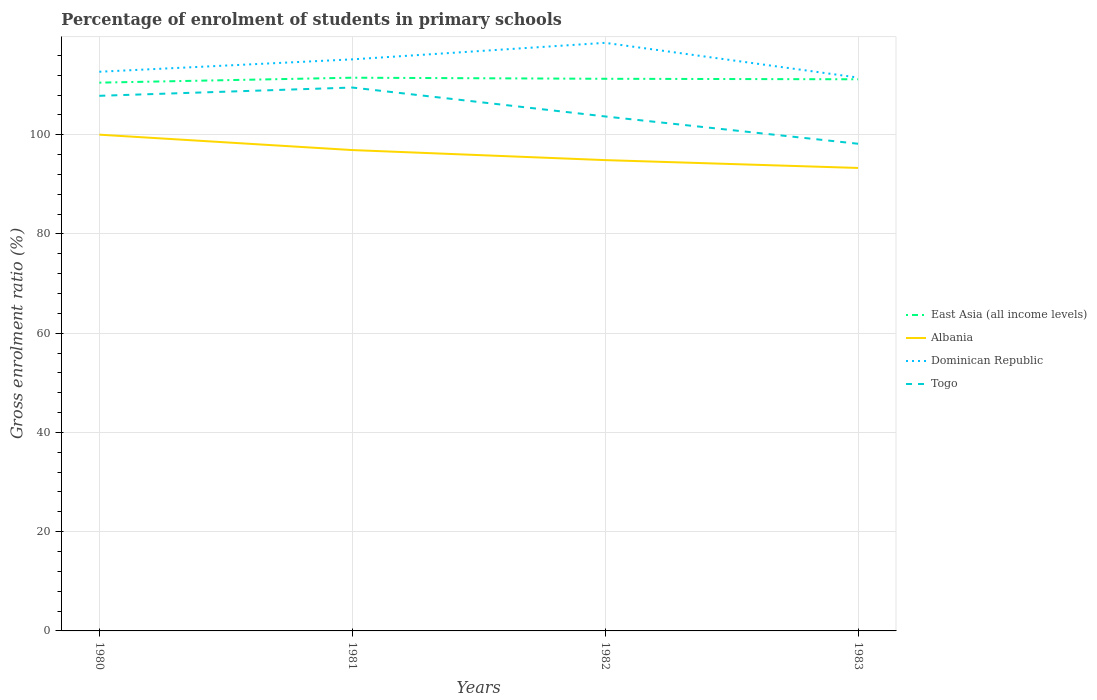Is the number of lines equal to the number of legend labels?
Your answer should be very brief. Yes. Across all years, what is the maximum percentage of students enrolled in primary schools in Dominican Republic?
Give a very brief answer. 111.51. What is the total percentage of students enrolled in primary schools in Dominican Republic in the graph?
Your answer should be very brief. 7. What is the difference between the highest and the second highest percentage of students enrolled in primary schools in Albania?
Offer a terse response. 6.71. What is the difference between the highest and the lowest percentage of students enrolled in primary schools in East Asia (all income levels)?
Offer a terse response. 3. How many lines are there?
Provide a succinct answer. 4. What is the difference between two consecutive major ticks on the Y-axis?
Keep it short and to the point. 20. Are the values on the major ticks of Y-axis written in scientific E-notation?
Your response must be concise. No. What is the title of the graph?
Provide a succinct answer. Percentage of enrolment of students in primary schools. Does "Cameroon" appear as one of the legend labels in the graph?
Provide a succinct answer. No. What is the label or title of the X-axis?
Keep it short and to the point. Years. What is the Gross enrolment ratio (%) of East Asia (all income levels) in 1980?
Keep it short and to the point. 110.49. What is the Gross enrolment ratio (%) of Albania in 1980?
Your answer should be compact. 100.01. What is the Gross enrolment ratio (%) in Dominican Republic in 1980?
Your answer should be compact. 112.69. What is the Gross enrolment ratio (%) of Togo in 1980?
Your answer should be very brief. 107.84. What is the Gross enrolment ratio (%) in East Asia (all income levels) in 1981?
Make the answer very short. 111.49. What is the Gross enrolment ratio (%) of Albania in 1981?
Offer a very short reply. 96.91. What is the Gross enrolment ratio (%) of Dominican Republic in 1981?
Your answer should be very brief. 115.18. What is the Gross enrolment ratio (%) in Togo in 1981?
Your answer should be very brief. 109.51. What is the Gross enrolment ratio (%) in East Asia (all income levels) in 1982?
Your answer should be compact. 111.27. What is the Gross enrolment ratio (%) of Albania in 1982?
Your answer should be compact. 94.88. What is the Gross enrolment ratio (%) in Dominican Republic in 1982?
Your answer should be compact. 118.52. What is the Gross enrolment ratio (%) of Togo in 1982?
Your answer should be compact. 103.68. What is the Gross enrolment ratio (%) of East Asia (all income levels) in 1983?
Provide a short and direct response. 111.17. What is the Gross enrolment ratio (%) in Albania in 1983?
Your response must be concise. 93.3. What is the Gross enrolment ratio (%) of Dominican Republic in 1983?
Your answer should be very brief. 111.51. What is the Gross enrolment ratio (%) in Togo in 1983?
Offer a terse response. 98.18. Across all years, what is the maximum Gross enrolment ratio (%) of East Asia (all income levels)?
Your answer should be very brief. 111.49. Across all years, what is the maximum Gross enrolment ratio (%) of Albania?
Ensure brevity in your answer.  100.01. Across all years, what is the maximum Gross enrolment ratio (%) in Dominican Republic?
Offer a very short reply. 118.52. Across all years, what is the maximum Gross enrolment ratio (%) in Togo?
Provide a short and direct response. 109.51. Across all years, what is the minimum Gross enrolment ratio (%) in East Asia (all income levels)?
Offer a terse response. 110.49. Across all years, what is the minimum Gross enrolment ratio (%) of Albania?
Offer a very short reply. 93.3. Across all years, what is the minimum Gross enrolment ratio (%) in Dominican Republic?
Provide a succinct answer. 111.51. Across all years, what is the minimum Gross enrolment ratio (%) in Togo?
Offer a very short reply. 98.18. What is the total Gross enrolment ratio (%) of East Asia (all income levels) in the graph?
Your response must be concise. 444.43. What is the total Gross enrolment ratio (%) in Albania in the graph?
Your answer should be very brief. 385.1. What is the total Gross enrolment ratio (%) of Dominican Republic in the graph?
Provide a succinct answer. 457.91. What is the total Gross enrolment ratio (%) in Togo in the graph?
Your answer should be compact. 419.21. What is the difference between the Gross enrolment ratio (%) in East Asia (all income levels) in 1980 and that in 1981?
Provide a short and direct response. -1. What is the difference between the Gross enrolment ratio (%) in Albania in 1980 and that in 1981?
Your answer should be compact. 3.1. What is the difference between the Gross enrolment ratio (%) in Dominican Republic in 1980 and that in 1981?
Provide a succinct answer. -2.49. What is the difference between the Gross enrolment ratio (%) of Togo in 1980 and that in 1981?
Ensure brevity in your answer.  -1.67. What is the difference between the Gross enrolment ratio (%) in East Asia (all income levels) in 1980 and that in 1982?
Make the answer very short. -0.78. What is the difference between the Gross enrolment ratio (%) of Albania in 1980 and that in 1982?
Keep it short and to the point. 5.13. What is the difference between the Gross enrolment ratio (%) in Dominican Republic in 1980 and that in 1982?
Provide a short and direct response. -5.83. What is the difference between the Gross enrolment ratio (%) of Togo in 1980 and that in 1982?
Provide a short and direct response. 4.16. What is the difference between the Gross enrolment ratio (%) of East Asia (all income levels) in 1980 and that in 1983?
Ensure brevity in your answer.  -0.68. What is the difference between the Gross enrolment ratio (%) in Albania in 1980 and that in 1983?
Make the answer very short. 6.71. What is the difference between the Gross enrolment ratio (%) in Dominican Republic in 1980 and that in 1983?
Offer a very short reply. 1.18. What is the difference between the Gross enrolment ratio (%) in Togo in 1980 and that in 1983?
Offer a very short reply. 9.66. What is the difference between the Gross enrolment ratio (%) in East Asia (all income levels) in 1981 and that in 1982?
Keep it short and to the point. 0.22. What is the difference between the Gross enrolment ratio (%) in Albania in 1981 and that in 1982?
Make the answer very short. 2.03. What is the difference between the Gross enrolment ratio (%) of Dominican Republic in 1981 and that in 1982?
Your answer should be compact. -3.33. What is the difference between the Gross enrolment ratio (%) of Togo in 1981 and that in 1982?
Your answer should be compact. 5.83. What is the difference between the Gross enrolment ratio (%) of East Asia (all income levels) in 1981 and that in 1983?
Provide a succinct answer. 0.32. What is the difference between the Gross enrolment ratio (%) of Albania in 1981 and that in 1983?
Your answer should be very brief. 3.61. What is the difference between the Gross enrolment ratio (%) in Dominican Republic in 1981 and that in 1983?
Provide a succinct answer. 3.67. What is the difference between the Gross enrolment ratio (%) of Togo in 1981 and that in 1983?
Keep it short and to the point. 11.33. What is the difference between the Gross enrolment ratio (%) in East Asia (all income levels) in 1982 and that in 1983?
Offer a terse response. 0.1. What is the difference between the Gross enrolment ratio (%) of Albania in 1982 and that in 1983?
Your response must be concise. 1.58. What is the difference between the Gross enrolment ratio (%) in Dominican Republic in 1982 and that in 1983?
Ensure brevity in your answer.  7. What is the difference between the Gross enrolment ratio (%) in Togo in 1982 and that in 1983?
Offer a very short reply. 5.5. What is the difference between the Gross enrolment ratio (%) in East Asia (all income levels) in 1980 and the Gross enrolment ratio (%) in Albania in 1981?
Ensure brevity in your answer.  13.59. What is the difference between the Gross enrolment ratio (%) in East Asia (all income levels) in 1980 and the Gross enrolment ratio (%) in Dominican Republic in 1981?
Ensure brevity in your answer.  -4.69. What is the difference between the Gross enrolment ratio (%) of East Asia (all income levels) in 1980 and the Gross enrolment ratio (%) of Togo in 1981?
Provide a succinct answer. 0.98. What is the difference between the Gross enrolment ratio (%) of Albania in 1980 and the Gross enrolment ratio (%) of Dominican Republic in 1981?
Offer a very short reply. -15.17. What is the difference between the Gross enrolment ratio (%) of Albania in 1980 and the Gross enrolment ratio (%) of Togo in 1981?
Offer a very short reply. -9.5. What is the difference between the Gross enrolment ratio (%) in Dominican Republic in 1980 and the Gross enrolment ratio (%) in Togo in 1981?
Your response must be concise. 3.18. What is the difference between the Gross enrolment ratio (%) of East Asia (all income levels) in 1980 and the Gross enrolment ratio (%) of Albania in 1982?
Offer a terse response. 15.61. What is the difference between the Gross enrolment ratio (%) of East Asia (all income levels) in 1980 and the Gross enrolment ratio (%) of Dominican Republic in 1982?
Offer a very short reply. -8.02. What is the difference between the Gross enrolment ratio (%) of East Asia (all income levels) in 1980 and the Gross enrolment ratio (%) of Togo in 1982?
Provide a short and direct response. 6.81. What is the difference between the Gross enrolment ratio (%) of Albania in 1980 and the Gross enrolment ratio (%) of Dominican Republic in 1982?
Provide a short and direct response. -18.51. What is the difference between the Gross enrolment ratio (%) of Albania in 1980 and the Gross enrolment ratio (%) of Togo in 1982?
Make the answer very short. -3.67. What is the difference between the Gross enrolment ratio (%) in Dominican Republic in 1980 and the Gross enrolment ratio (%) in Togo in 1982?
Provide a succinct answer. 9.01. What is the difference between the Gross enrolment ratio (%) in East Asia (all income levels) in 1980 and the Gross enrolment ratio (%) in Albania in 1983?
Provide a succinct answer. 17.19. What is the difference between the Gross enrolment ratio (%) in East Asia (all income levels) in 1980 and the Gross enrolment ratio (%) in Dominican Republic in 1983?
Keep it short and to the point. -1.02. What is the difference between the Gross enrolment ratio (%) in East Asia (all income levels) in 1980 and the Gross enrolment ratio (%) in Togo in 1983?
Your response must be concise. 12.32. What is the difference between the Gross enrolment ratio (%) in Albania in 1980 and the Gross enrolment ratio (%) in Dominican Republic in 1983?
Make the answer very short. -11.5. What is the difference between the Gross enrolment ratio (%) of Albania in 1980 and the Gross enrolment ratio (%) of Togo in 1983?
Your answer should be compact. 1.83. What is the difference between the Gross enrolment ratio (%) of Dominican Republic in 1980 and the Gross enrolment ratio (%) of Togo in 1983?
Offer a very short reply. 14.51. What is the difference between the Gross enrolment ratio (%) of East Asia (all income levels) in 1981 and the Gross enrolment ratio (%) of Albania in 1982?
Keep it short and to the point. 16.61. What is the difference between the Gross enrolment ratio (%) in East Asia (all income levels) in 1981 and the Gross enrolment ratio (%) in Dominican Republic in 1982?
Your answer should be compact. -7.03. What is the difference between the Gross enrolment ratio (%) in East Asia (all income levels) in 1981 and the Gross enrolment ratio (%) in Togo in 1982?
Keep it short and to the point. 7.81. What is the difference between the Gross enrolment ratio (%) of Albania in 1981 and the Gross enrolment ratio (%) of Dominican Republic in 1982?
Keep it short and to the point. -21.61. What is the difference between the Gross enrolment ratio (%) of Albania in 1981 and the Gross enrolment ratio (%) of Togo in 1982?
Provide a succinct answer. -6.77. What is the difference between the Gross enrolment ratio (%) of Dominican Republic in 1981 and the Gross enrolment ratio (%) of Togo in 1982?
Make the answer very short. 11.5. What is the difference between the Gross enrolment ratio (%) in East Asia (all income levels) in 1981 and the Gross enrolment ratio (%) in Albania in 1983?
Make the answer very short. 18.19. What is the difference between the Gross enrolment ratio (%) in East Asia (all income levels) in 1981 and the Gross enrolment ratio (%) in Dominican Republic in 1983?
Make the answer very short. -0.02. What is the difference between the Gross enrolment ratio (%) of East Asia (all income levels) in 1981 and the Gross enrolment ratio (%) of Togo in 1983?
Provide a short and direct response. 13.31. What is the difference between the Gross enrolment ratio (%) of Albania in 1981 and the Gross enrolment ratio (%) of Dominican Republic in 1983?
Provide a succinct answer. -14.61. What is the difference between the Gross enrolment ratio (%) in Albania in 1981 and the Gross enrolment ratio (%) in Togo in 1983?
Your answer should be compact. -1.27. What is the difference between the Gross enrolment ratio (%) of Dominican Republic in 1981 and the Gross enrolment ratio (%) of Togo in 1983?
Provide a succinct answer. 17.01. What is the difference between the Gross enrolment ratio (%) of East Asia (all income levels) in 1982 and the Gross enrolment ratio (%) of Albania in 1983?
Ensure brevity in your answer.  17.97. What is the difference between the Gross enrolment ratio (%) in East Asia (all income levels) in 1982 and the Gross enrolment ratio (%) in Dominican Republic in 1983?
Your response must be concise. -0.24. What is the difference between the Gross enrolment ratio (%) in East Asia (all income levels) in 1982 and the Gross enrolment ratio (%) in Togo in 1983?
Your answer should be very brief. 13.09. What is the difference between the Gross enrolment ratio (%) of Albania in 1982 and the Gross enrolment ratio (%) of Dominican Republic in 1983?
Make the answer very short. -16.63. What is the difference between the Gross enrolment ratio (%) of Albania in 1982 and the Gross enrolment ratio (%) of Togo in 1983?
Give a very brief answer. -3.3. What is the difference between the Gross enrolment ratio (%) in Dominican Republic in 1982 and the Gross enrolment ratio (%) in Togo in 1983?
Offer a terse response. 20.34. What is the average Gross enrolment ratio (%) of East Asia (all income levels) per year?
Your response must be concise. 111.11. What is the average Gross enrolment ratio (%) in Albania per year?
Keep it short and to the point. 96.28. What is the average Gross enrolment ratio (%) in Dominican Republic per year?
Make the answer very short. 114.48. What is the average Gross enrolment ratio (%) of Togo per year?
Offer a terse response. 104.8. In the year 1980, what is the difference between the Gross enrolment ratio (%) of East Asia (all income levels) and Gross enrolment ratio (%) of Albania?
Provide a short and direct response. 10.48. In the year 1980, what is the difference between the Gross enrolment ratio (%) of East Asia (all income levels) and Gross enrolment ratio (%) of Dominican Republic?
Your answer should be compact. -2.2. In the year 1980, what is the difference between the Gross enrolment ratio (%) in East Asia (all income levels) and Gross enrolment ratio (%) in Togo?
Make the answer very short. 2.65. In the year 1980, what is the difference between the Gross enrolment ratio (%) in Albania and Gross enrolment ratio (%) in Dominican Republic?
Your answer should be very brief. -12.68. In the year 1980, what is the difference between the Gross enrolment ratio (%) in Albania and Gross enrolment ratio (%) in Togo?
Keep it short and to the point. -7.83. In the year 1980, what is the difference between the Gross enrolment ratio (%) in Dominican Republic and Gross enrolment ratio (%) in Togo?
Give a very brief answer. 4.85. In the year 1981, what is the difference between the Gross enrolment ratio (%) in East Asia (all income levels) and Gross enrolment ratio (%) in Albania?
Provide a short and direct response. 14.58. In the year 1981, what is the difference between the Gross enrolment ratio (%) in East Asia (all income levels) and Gross enrolment ratio (%) in Dominican Republic?
Make the answer very short. -3.7. In the year 1981, what is the difference between the Gross enrolment ratio (%) in East Asia (all income levels) and Gross enrolment ratio (%) in Togo?
Provide a succinct answer. 1.98. In the year 1981, what is the difference between the Gross enrolment ratio (%) in Albania and Gross enrolment ratio (%) in Dominican Republic?
Offer a terse response. -18.28. In the year 1981, what is the difference between the Gross enrolment ratio (%) in Albania and Gross enrolment ratio (%) in Togo?
Offer a very short reply. -12.6. In the year 1981, what is the difference between the Gross enrolment ratio (%) of Dominican Republic and Gross enrolment ratio (%) of Togo?
Your answer should be very brief. 5.68. In the year 1982, what is the difference between the Gross enrolment ratio (%) in East Asia (all income levels) and Gross enrolment ratio (%) in Albania?
Your answer should be compact. 16.39. In the year 1982, what is the difference between the Gross enrolment ratio (%) in East Asia (all income levels) and Gross enrolment ratio (%) in Dominican Republic?
Offer a terse response. -7.25. In the year 1982, what is the difference between the Gross enrolment ratio (%) of East Asia (all income levels) and Gross enrolment ratio (%) of Togo?
Ensure brevity in your answer.  7.59. In the year 1982, what is the difference between the Gross enrolment ratio (%) of Albania and Gross enrolment ratio (%) of Dominican Republic?
Provide a short and direct response. -23.64. In the year 1982, what is the difference between the Gross enrolment ratio (%) of Dominican Republic and Gross enrolment ratio (%) of Togo?
Offer a very short reply. 14.84. In the year 1983, what is the difference between the Gross enrolment ratio (%) of East Asia (all income levels) and Gross enrolment ratio (%) of Albania?
Offer a very short reply. 17.87. In the year 1983, what is the difference between the Gross enrolment ratio (%) of East Asia (all income levels) and Gross enrolment ratio (%) of Dominican Republic?
Provide a succinct answer. -0.34. In the year 1983, what is the difference between the Gross enrolment ratio (%) in East Asia (all income levels) and Gross enrolment ratio (%) in Togo?
Provide a short and direct response. 12.99. In the year 1983, what is the difference between the Gross enrolment ratio (%) in Albania and Gross enrolment ratio (%) in Dominican Republic?
Your response must be concise. -18.21. In the year 1983, what is the difference between the Gross enrolment ratio (%) in Albania and Gross enrolment ratio (%) in Togo?
Provide a succinct answer. -4.88. In the year 1983, what is the difference between the Gross enrolment ratio (%) of Dominican Republic and Gross enrolment ratio (%) of Togo?
Offer a very short reply. 13.34. What is the ratio of the Gross enrolment ratio (%) of Albania in 1980 to that in 1981?
Offer a very short reply. 1.03. What is the ratio of the Gross enrolment ratio (%) of Dominican Republic in 1980 to that in 1981?
Give a very brief answer. 0.98. What is the ratio of the Gross enrolment ratio (%) in Togo in 1980 to that in 1981?
Offer a terse response. 0.98. What is the ratio of the Gross enrolment ratio (%) in East Asia (all income levels) in 1980 to that in 1982?
Offer a terse response. 0.99. What is the ratio of the Gross enrolment ratio (%) of Albania in 1980 to that in 1982?
Your response must be concise. 1.05. What is the ratio of the Gross enrolment ratio (%) in Dominican Republic in 1980 to that in 1982?
Make the answer very short. 0.95. What is the ratio of the Gross enrolment ratio (%) of Togo in 1980 to that in 1982?
Ensure brevity in your answer.  1.04. What is the ratio of the Gross enrolment ratio (%) in Albania in 1980 to that in 1983?
Your response must be concise. 1.07. What is the ratio of the Gross enrolment ratio (%) of Dominican Republic in 1980 to that in 1983?
Your answer should be very brief. 1.01. What is the ratio of the Gross enrolment ratio (%) in Togo in 1980 to that in 1983?
Your response must be concise. 1.1. What is the ratio of the Gross enrolment ratio (%) of Albania in 1981 to that in 1982?
Provide a succinct answer. 1.02. What is the ratio of the Gross enrolment ratio (%) of Dominican Republic in 1981 to that in 1982?
Your response must be concise. 0.97. What is the ratio of the Gross enrolment ratio (%) of Togo in 1981 to that in 1982?
Keep it short and to the point. 1.06. What is the ratio of the Gross enrolment ratio (%) of Albania in 1981 to that in 1983?
Offer a very short reply. 1.04. What is the ratio of the Gross enrolment ratio (%) of Dominican Republic in 1981 to that in 1983?
Your answer should be compact. 1.03. What is the ratio of the Gross enrolment ratio (%) in Togo in 1981 to that in 1983?
Keep it short and to the point. 1.12. What is the ratio of the Gross enrolment ratio (%) in East Asia (all income levels) in 1982 to that in 1983?
Give a very brief answer. 1. What is the ratio of the Gross enrolment ratio (%) in Albania in 1982 to that in 1983?
Your answer should be compact. 1.02. What is the ratio of the Gross enrolment ratio (%) of Dominican Republic in 1982 to that in 1983?
Offer a terse response. 1.06. What is the ratio of the Gross enrolment ratio (%) in Togo in 1982 to that in 1983?
Give a very brief answer. 1.06. What is the difference between the highest and the second highest Gross enrolment ratio (%) of East Asia (all income levels)?
Offer a very short reply. 0.22. What is the difference between the highest and the second highest Gross enrolment ratio (%) in Albania?
Ensure brevity in your answer.  3.1. What is the difference between the highest and the second highest Gross enrolment ratio (%) in Dominican Republic?
Keep it short and to the point. 3.33. What is the difference between the highest and the second highest Gross enrolment ratio (%) in Togo?
Your answer should be very brief. 1.67. What is the difference between the highest and the lowest Gross enrolment ratio (%) of Albania?
Keep it short and to the point. 6.71. What is the difference between the highest and the lowest Gross enrolment ratio (%) in Dominican Republic?
Ensure brevity in your answer.  7. What is the difference between the highest and the lowest Gross enrolment ratio (%) in Togo?
Your answer should be compact. 11.33. 